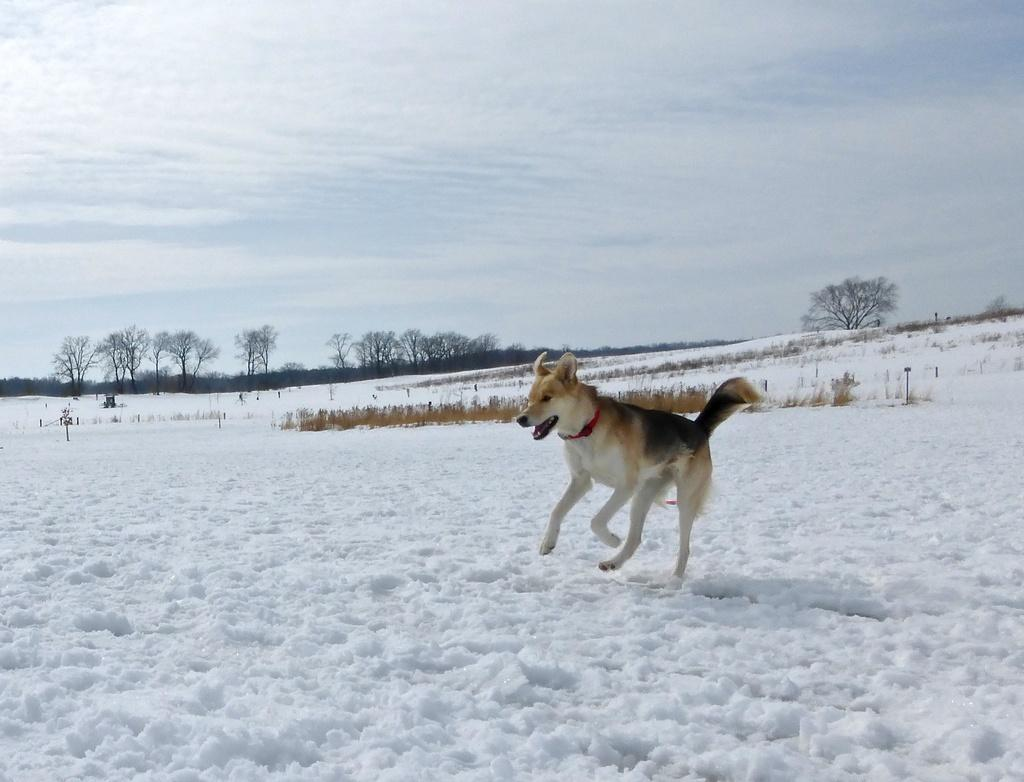What is the main subject in the center of the image? There is a dog in the center of the image. What can be seen in the background of the image? There are trees and the sky visible in the background of the image. What is the weather like in the image? The presence of snow at the bottom of the image suggests that it is snowing or has recently snowed. What else can be seen in the sky? Clouds are present in the background of the image. What type of liquid is the dog drinking from the stove in the image? There is no stove or liquid present in the image; it features a dog in a snowy environment with trees, sky, and clouds in the background. 